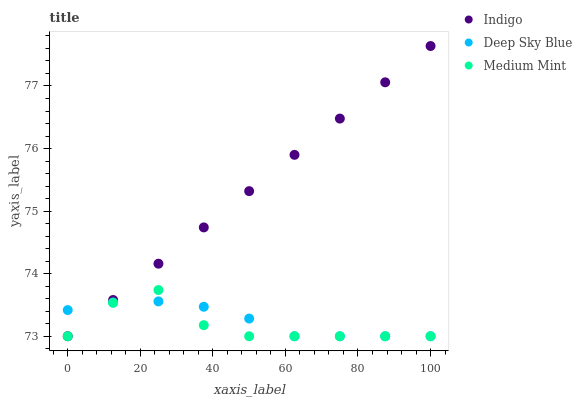Does Medium Mint have the minimum area under the curve?
Answer yes or no. Yes. Does Indigo have the maximum area under the curve?
Answer yes or no. Yes. Does Deep Sky Blue have the minimum area under the curve?
Answer yes or no. No. Does Deep Sky Blue have the maximum area under the curve?
Answer yes or no. No. Is Indigo the smoothest?
Answer yes or no. Yes. Is Medium Mint the roughest?
Answer yes or no. Yes. Is Deep Sky Blue the smoothest?
Answer yes or no. No. Is Deep Sky Blue the roughest?
Answer yes or no. No. Does Medium Mint have the lowest value?
Answer yes or no. Yes. Does Indigo have the highest value?
Answer yes or no. Yes. Does Deep Sky Blue have the highest value?
Answer yes or no. No. Does Indigo intersect Medium Mint?
Answer yes or no. Yes. Is Indigo less than Medium Mint?
Answer yes or no. No. Is Indigo greater than Medium Mint?
Answer yes or no. No. 